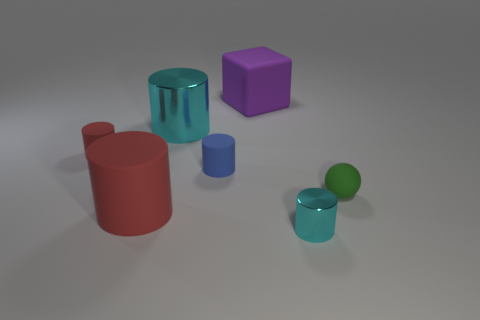Is there anything else that has the same shape as the big purple object?
Your answer should be very brief. No. What material is the tiny thing that is the same color as the big matte cylinder?
Ensure brevity in your answer.  Rubber. There is a cyan object in front of the cyan metal cylinder behind the green matte ball; are there any large cyan objects that are on the right side of it?
Provide a succinct answer. No. Is the number of small spheres that are behind the tiny red matte thing less than the number of big objects that are right of the tiny blue object?
Offer a terse response. Yes. There is a small cylinder that is made of the same material as the tiny red object; what color is it?
Your answer should be compact. Blue. What color is the small object that is to the left of the metallic thing that is on the left side of the tiny metal object?
Provide a succinct answer. Red. Is there a metal cylinder of the same color as the tiny shiny thing?
Provide a succinct answer. Yes. The red object that is the same size as the purple object is what shape?
Keep it short and to the point. Cylinder. There is a big cylinder that is in front of the tiny blue thing; what number of tiny blue objects are in front of it?
Keep it short and to the point. 0. Is the color of the tiny metallic cylinder the same as the big shiny object?
Ensure brevity in your answer.  Yes. 